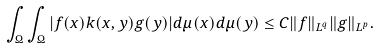<formula> <loc_0><loc_0><loc_500><loc_500>\int _ { \Omega } \int _ { \Omega } | f ( x ) k ( x , y ) g ( y ) | d \mu ( x ) d \mu ( y ) \leq C \| f \| _ { L ^ { q } } \| g \| _ { L ^ { p } } .</formula> 